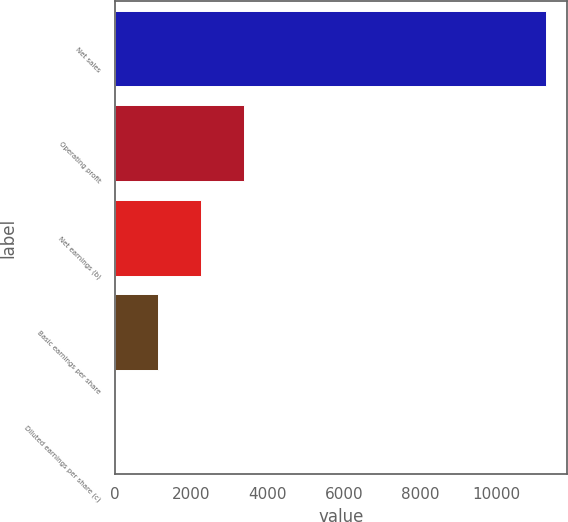Convert chart. <chart><loc_0><loc_0><loc_500><loc_500><bar_chart><fcel>Net sales<fcel>Operating profit<fcel>Net earnings (b)<fcel>Basic earnings per share<fcel>Diluted earnings per share (c)<nl><fcel>11293<fcel>3389.33<fcel>2260.23<fcel>1131.13<fcel>2.03<nl></chart> 